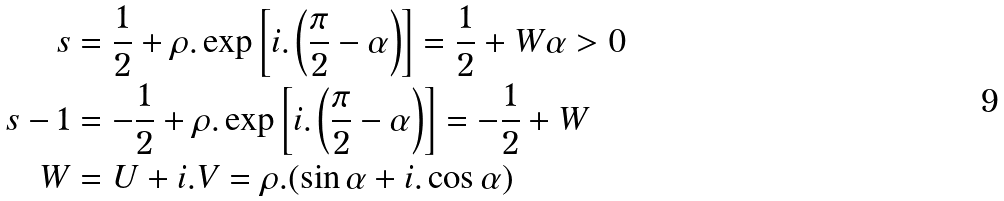Convert formula to latex. <formula><loc_0><loc_0><loc_500><loc_500>s & = \frac { 1 } { 2 } + \rho . \exp \left [ i . \left ( \frac { \pi } { 2 } - \alpha \right ) \right ] = \frac { 1 } { 2 } + W \alpha > 0 \\ s - 1 & = - \frac { 1 } { 2 } + \rho . \exp \left [ i . \left ( \frac { \pi } { 2 } - \alpha \right ) \right ] = - \frac { 1 } { 2 } + W \\ W & = U + i . V = \rho . ( \sin \alpha + i . \cos \alpha )</formula> 